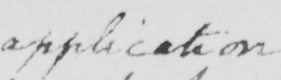Can you tell me what this handwritten text says? application 